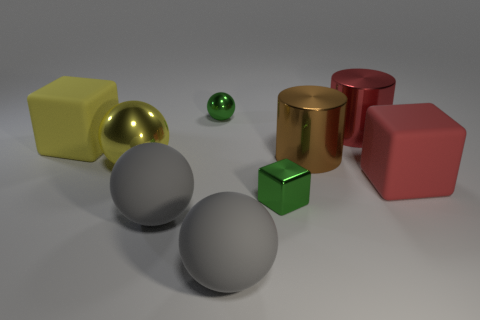Subtract all yellow cubes. How many cubes are left? 2 Subtract all small blue spheres. Subtract all red blocks. How many objects are left? 8 Add 5 large rubber cubes. How many large rubber cubes are left? 7 Add 6 yellow metallic blocks. How many yellow metallic blocks exist? 6 Subtract all yellow spheres. How many spheres are left? 3 Subtract 1 red blocks. How many objects are left? 8 Subtract all cubes. How many objects are left? 6 Subtract 1 spheres. How many spheres are left? 3 Subtract all red spheres. Subtract all brown cylinders. How many spheres are left? 4 Subtract all brown cylinders. How many yellow blocks are left? 1 